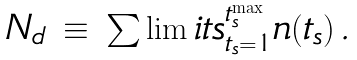<formula> <loc_0><loc_0><loc_500><loc_500>\begin{array} { c c c } N _ { d } & \equiv & \sum \lim i t s _ { t _ { s } = 1 } ^ { t _ { s } ^ { \max } } n ( t _ { s } ) \, . \\ \end{array}</formula> 